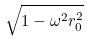<formula> <loc_0><loc_0><loc_500><loc_500>\sqrt { 1 - \omega ^ { 2 } r _ { 0 } ^ { 2 } }</formula> 